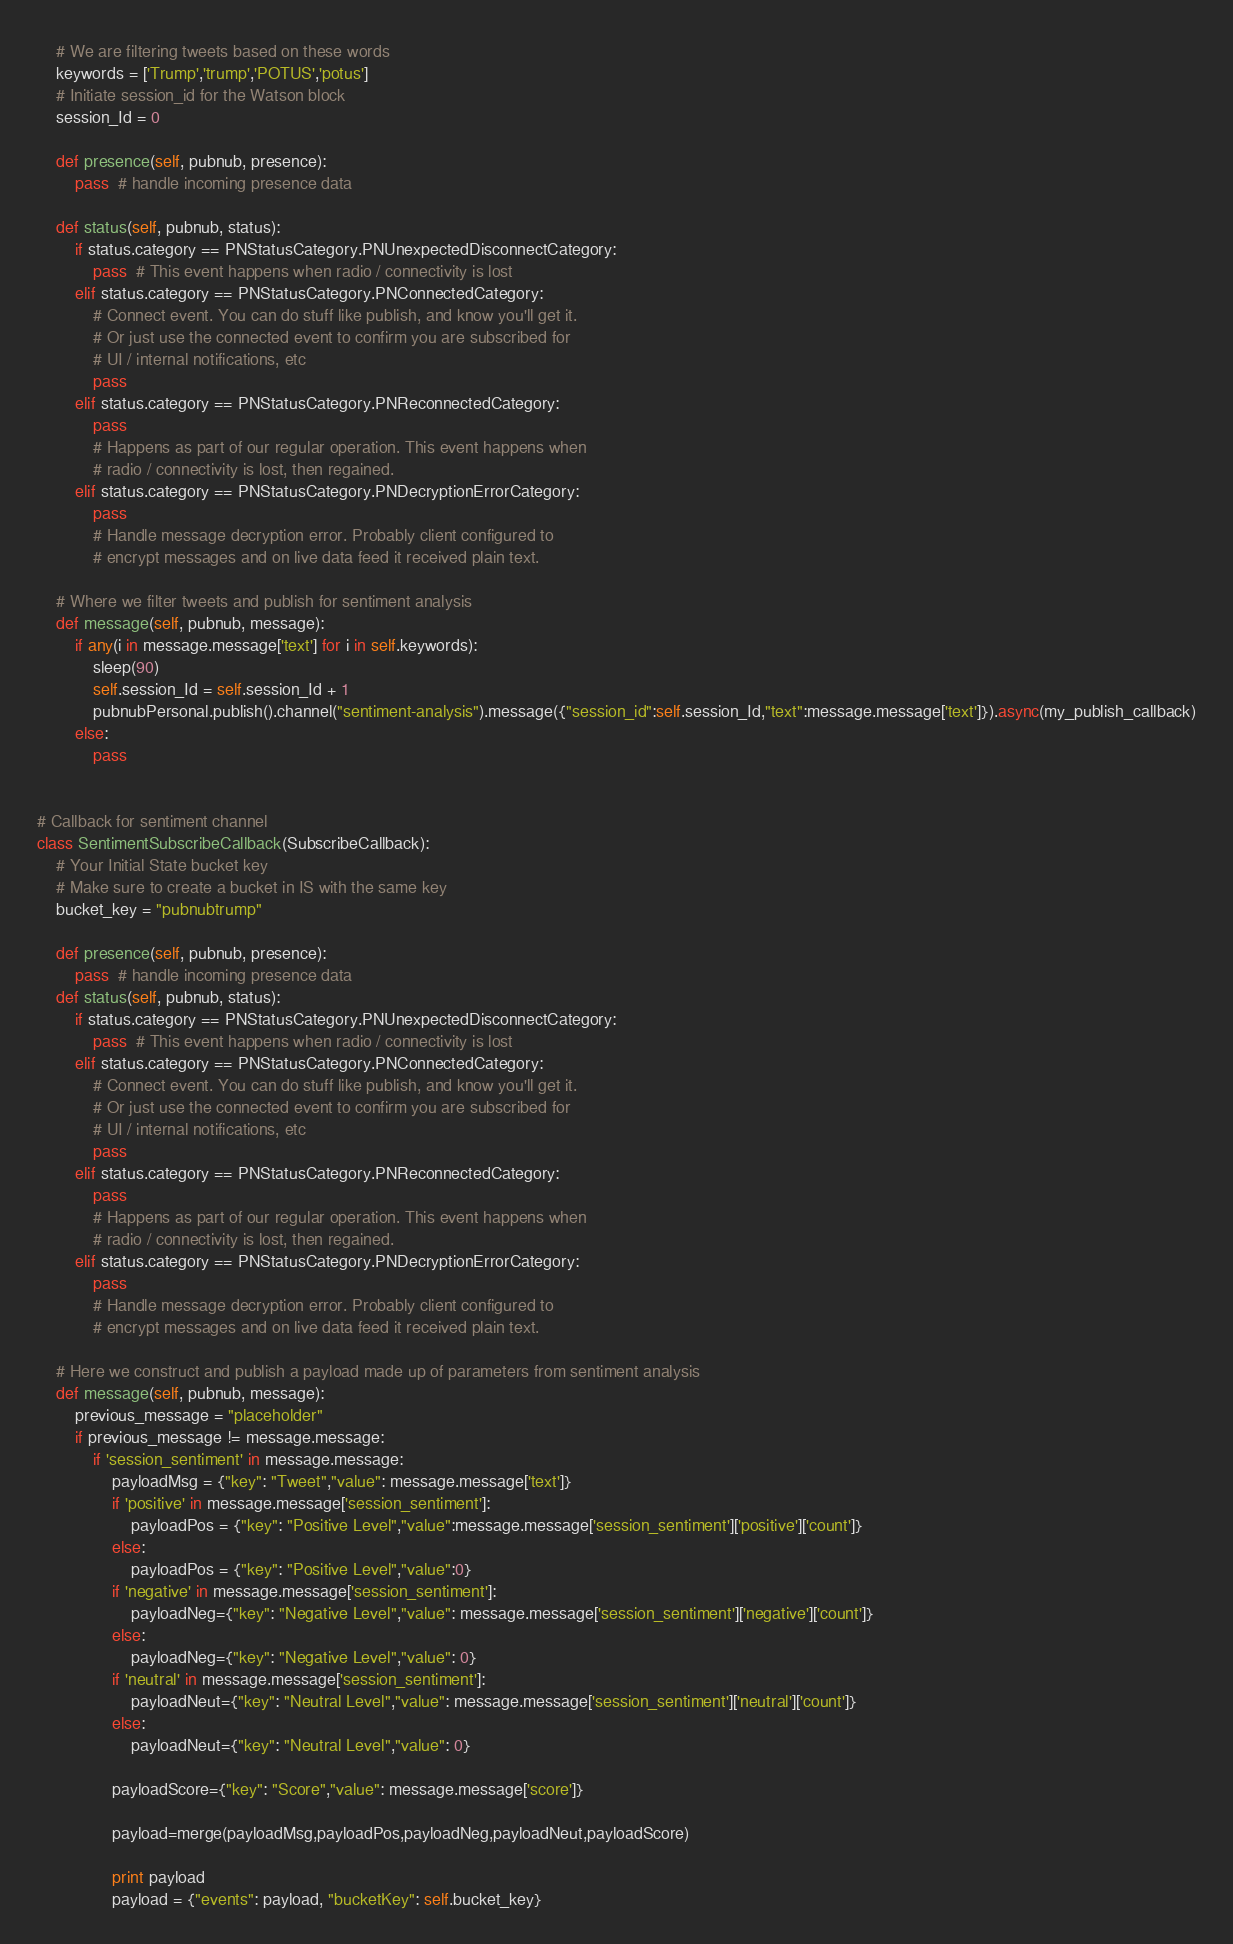<code> <loc_0><loc_0><loc_500><loc_500><_Python_>
    # We are filtering tweets based on these words
    keywords = ['Trump','trump','POTUS','potus']
    # Initiate session_id for the Watson block
    session_Id = 0

    def presence(self, pubnub, presence):
        pass  # handle incoming presence data
 
    def status(self, pubnub, status):
        if status.category == PNStatusCategory.PNUnexpectedDisconnectCategory:
            pass  # This event happens when radio / connectivity is lost 
        elif status.category == PNStatusCategory.PNConnectedCategory:
            # Connect event. You can do stuff like publish, and know you'll get it.
            # Or just use the connected event to confirm you are subscribed for
            # UI / internal notifications, etc
            pass
        elif status.category == PNStatusCategory.PNReconnectedCategory:
            pass
            # Happens as part of our regular operation. This event happens when
            # radio / connectivity is lost, then regained.
        elif status.category == PNStatusCategory.PNDecryptionErrorCategory:
            pass
            # Handle message decryption error. Probably client configured to
            # encrypt messages and on live data feed it received plain text.

    # Where we filter tweets and publish for sentiment analysis
    def message(self, pubnub, message):
        if any(i in message.message['text'] for i in self.keywords):
            sleep(90)
            self.session_Id = self.session_Id + 1
            pubnubPersonal.publish().channel("sentiment-analysis").message({"session_id":self.session_Id,"text":message.message['text']}).async(my_publish_callback)
        else:
            pass
            

# Callback for sentiment channel        
class SentimentSubscribeCallback(SubscribeCallback):
    # Your Initial State bucket key
    # Make sure to create a bucket in IS with the same key
    bucket_key = "pubnubtrump"

    def presence(self, pubnub, presence):
        pass  # handle incoming presence data
    def status(self, pubnub, status):
        if status.category == PNStatusCategory.PNUnexpectedDisconnectCategory:
            pass  # This event happens when radio / connectivity is lost
        elif status.category == PNStatusCategory.PNConnectedCategory:
            # Connect event. You can do stuff like publish, and know you'll get it.
            # Or just use the connected event to confirm you are subscribed for
            # UI / internal notifications, etc
            pass
        elif status.category == PNStatusCategory.PNReconnectedCategory:
            pass
            # Happens as part of our regular operation. This event happens when
            # radio / connectivity is lost, then regained.
        elif status.category == PNStatusCategory.PNDecryptionErrorCategory:
            pass
            # Handle message decryption error. Probably client configured to
            # encrypt messages and on live data feed it received plain text.
    
    # Here we construct and publish a payload made up of parameters from sentiment analysis
    def message(self, pubnub, message):
        previous_message = "placeholder"
        if previous_message != message.message:
            if 'session_sentiment' in message.message:
                payloadMsg = {"key": "Tweet","value": message.message['text']}
                if 'positive' in message.message['session_sentiment']:
                    payloadPos = {"key": "Positive Level","value":message.message['session_sentiment']['positive']['count']}
                else:
                    payloadPos = {"key": "Positive Level","value":0}
                if 'negative' in message.message['session_sentiment']:
                    payloadNeg={"key": "Negative Level","value": message.message['session_sentiment']['negative']['count']}
                else:
                    payloadNeg={"key": "Negative Level","value": 0}
                if 'neutral' in message.message['session_sentiment']:
                    payloadNeut={"key": "Neutral Level","value": message.message['session_sentiment']['neutral']['count']}
                else:
                    payloadNeut={"key": "Neutral Level","value": 0}

                payloadScore={"key": "Score","value": message.message['score']}
                
                payload=merge(payloadMsg,payloadPos,payloadNeg,payloadNeut,payloadScore)
                
                print payload
                payload = {"events": payload, "bucketKey": self.bucket_key}
</code> 